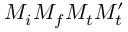Convert formula to latex. <formula><loc_0><loc_0><loc_500><loc_500>M _ { i } M _ { f } M _ { t } M _ { t } ^ { \prime }</formula> 